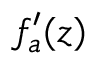Convert formula to latex. <formula><loc_0><loc_0><loc_500><loc_500>f _ { a } ^ { \prime } ( z )</formula> 